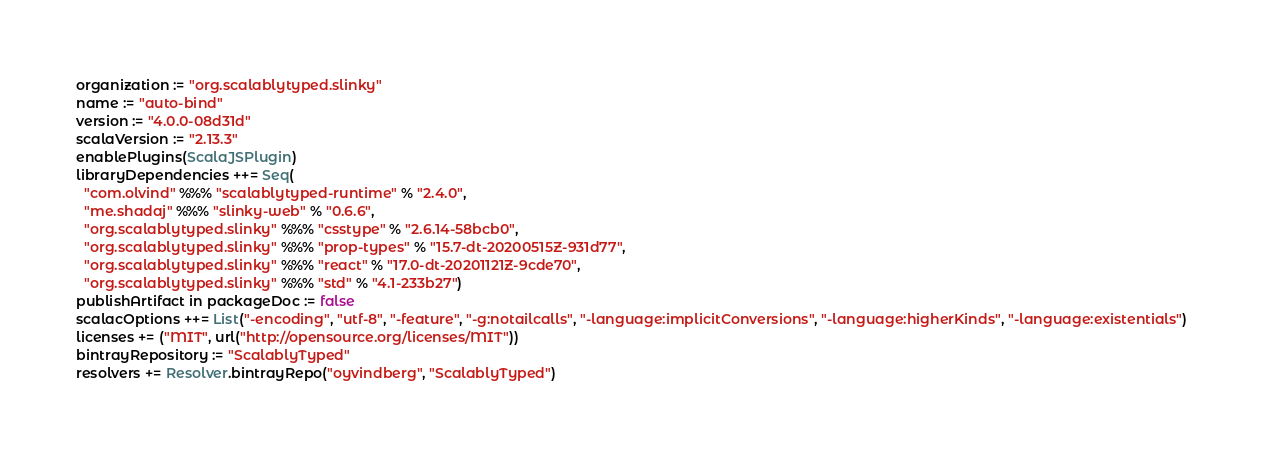<code> <loc_0><loc_0><loc_500><loc_500><_Scala_>organization := "org.scalablytyped.slinky"
name := "auto-bind"
version := "4.0.0-08d31d"
scalaVersion := "2.13.3"
enablePlugins(ScalaJSPlugin)
libraryDependencies ++= Seq(
  "com.olvind" %%% "scalablytyped-runtime" % "2.4.0",
  "me.shadaj" %%% "slinky-web" % "0.6.6",
  "org.scalablytyped.slinky" %%% "csstype" % "2.6.14-58bcb0",
  "org.scalablytyped.slinky" %%% "prop-types" % "15.7-dt-20200515Z-931d77",
  "org.scalablytyped.slinky" %%% "react" % "17.0-dt-20201121Z-9cde70",
  "org.scalablytyped.slinky" %%% "std" % "4.1-233b27")
publishArtifact in packageDoc := false
scalacOptions ++= List("-encoding", "utf-8", "-feature", "-g:notailcalls", "-language:implicitConversions", "-language:higherKinds", "-language:existentials")
licenses += ("MIT", url("http://opensource.org/licenses/MIT"))
bintrayRepository := "ScalablyTyped"
resolvers += Resolver.bintrayRepo("oyvindberg", "ScalablyTyped")
</code> 